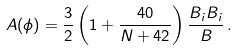<formula> <loc_0><loc_0><loc_500><loc_500>A ( \phi ) = \frac { 3 } { 2 } \left ( 1 + \frac { 4 0 } { N + 4 2 } \right ) \frac { B _ { i } B _ { i } } { B } \, .</formula> 